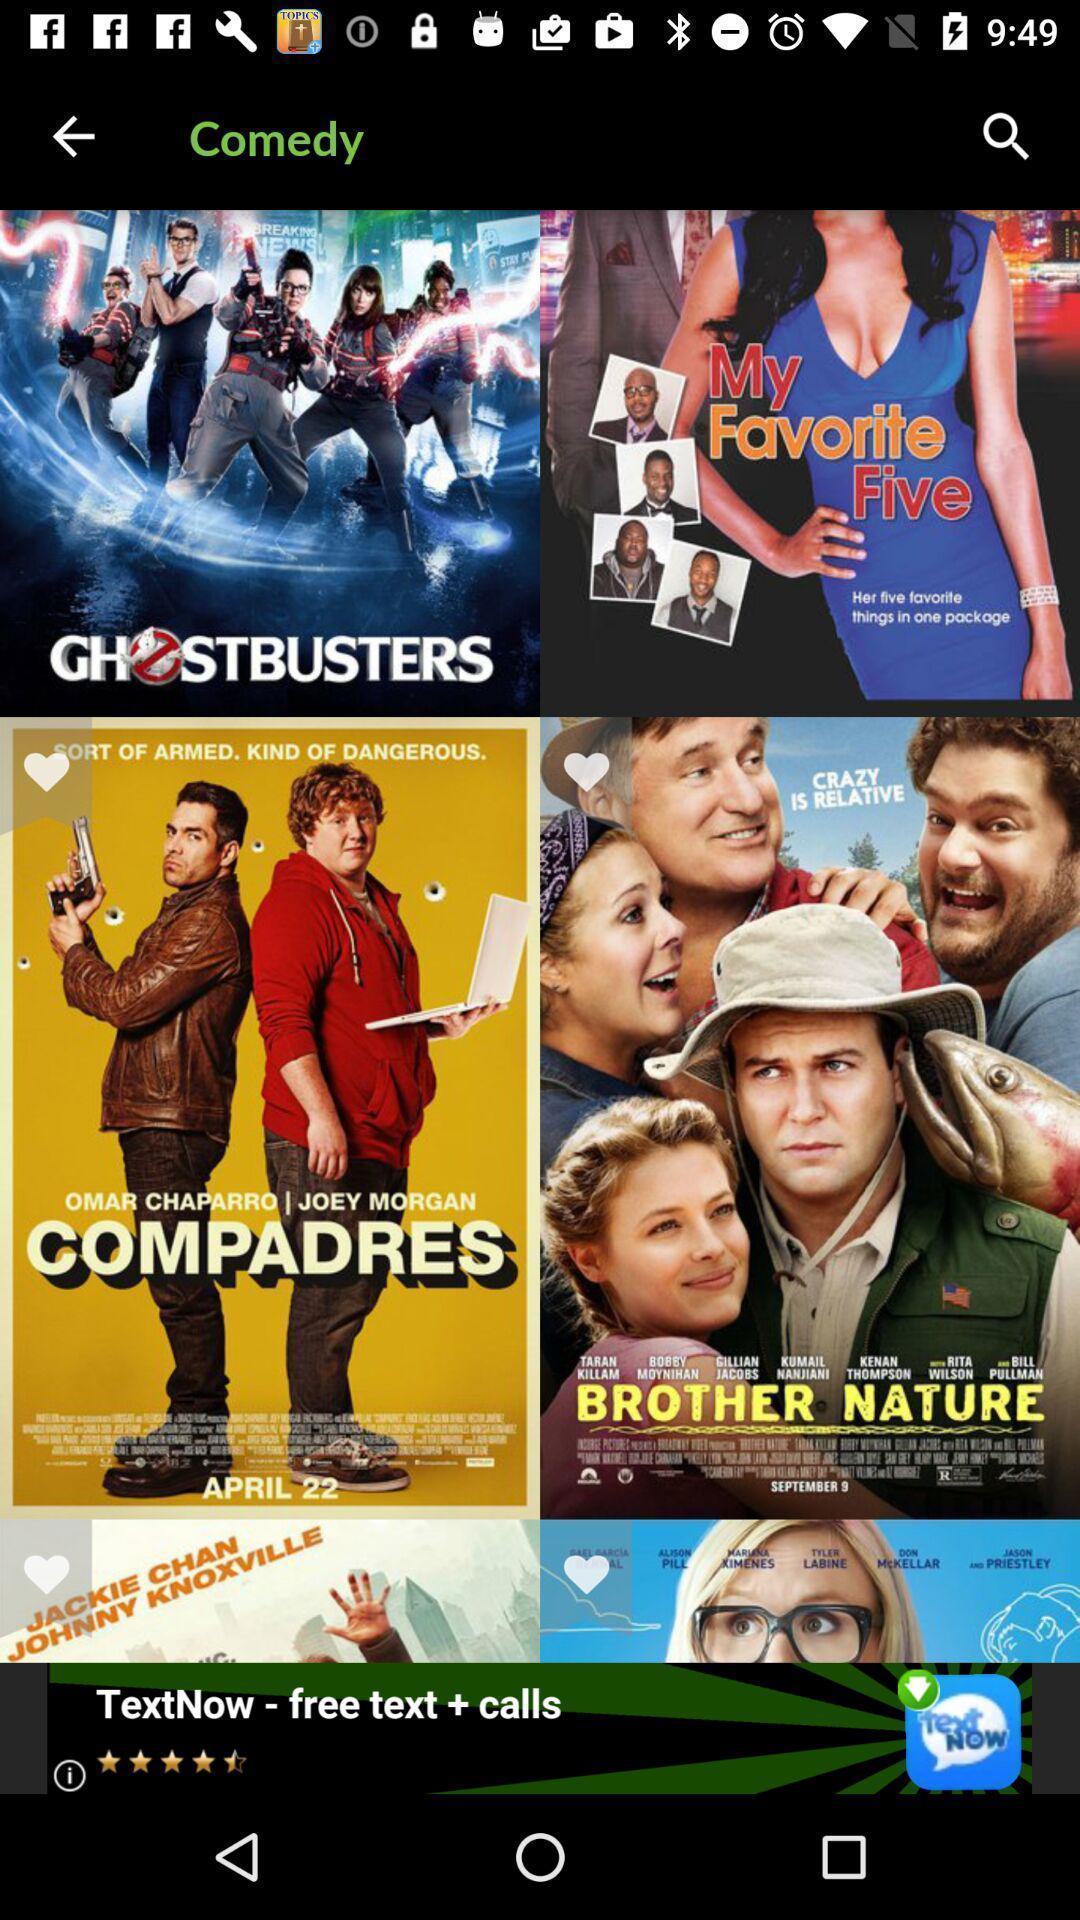Provide a textual representation of this image. Screen displaying multiple movie names with pictures. 